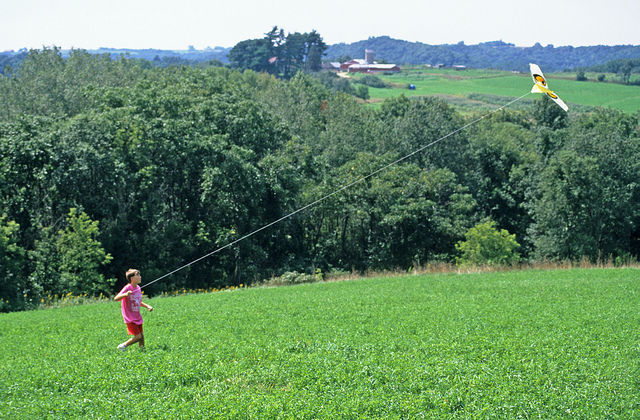Where is the child standing while flying the kite? The child is standing on a grassy hill with an array of trees nearby, providing a beautiful green backdrop as they fly the kite. The open green meadow beyond the town suggests a rural setting, ideal for such activities. 